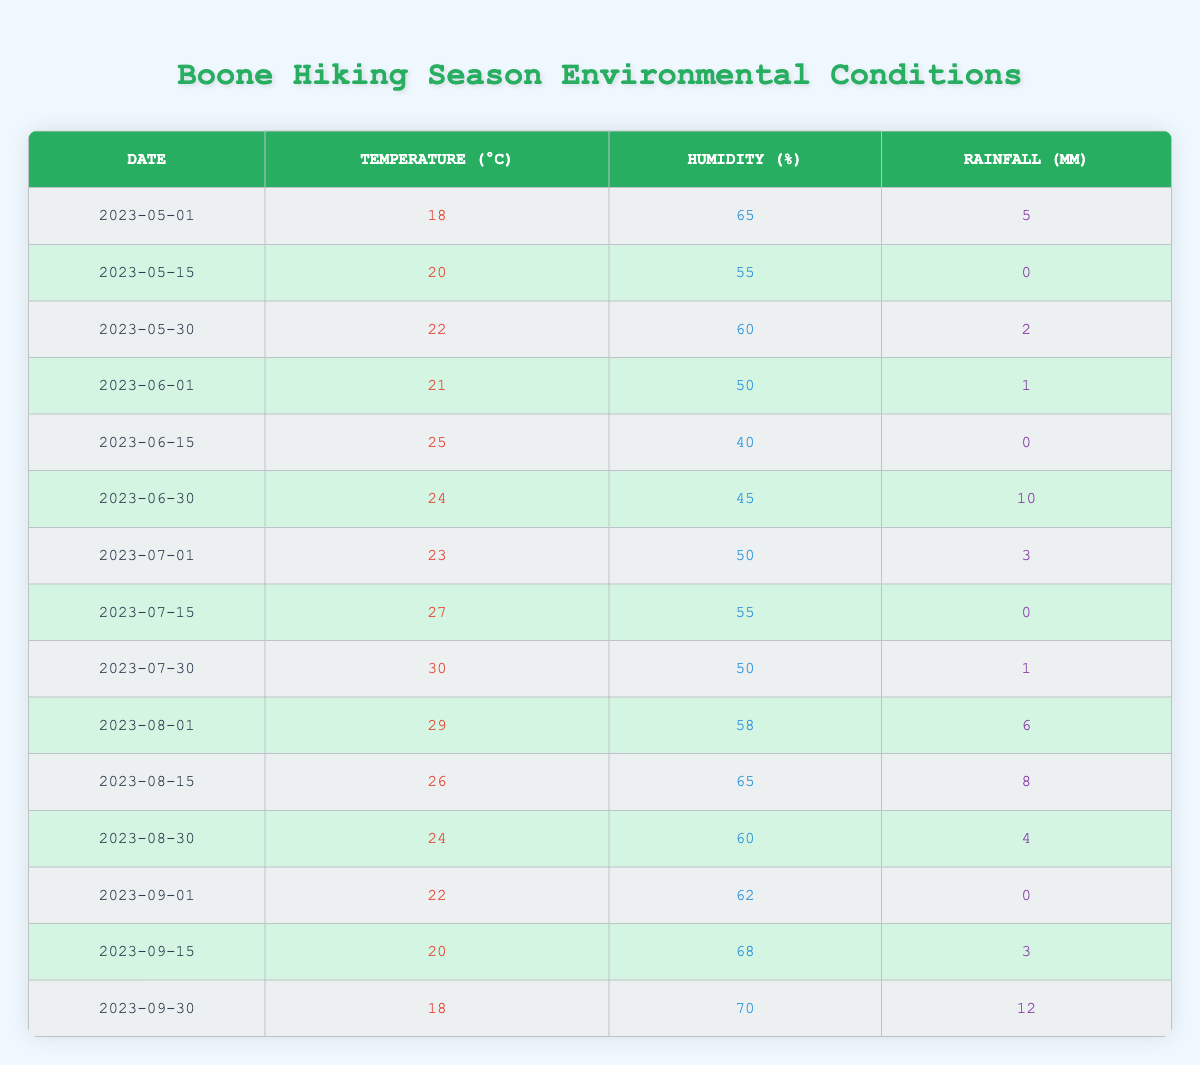What was the maximum temperature recorded during the hiking season? The maximum temperature can be found by scanning the temperature values in the table. The highest listed is 30°C on July 30, 2023.
Answer: 30°C What was the lowest humidity percentage recorded in the hiking season? By examining the humidity values, the lowest percentage is 40%, which occurred on June 15, 2023.
Answer: 40% How much total rainfall was recorded from May to September 2023? Adding the rainfall values: 5 + 0 + 2 + 1 + 0 + 10 + 3 + 0 + 1 + 6 + 8 + 4 + 0 + 3 + 12 = 51 mm. Thus, total rainfall is 51 mm.
Answer: 51 mm Which date had the highest humidity? By checking the humidity values, the highest percentage is 70%, recorded on September 30, 2023.
Answer: September 30, 2023 What is the average temperature across the hiking season? The temperatures are 18, 20, 22, 21, 25, 24, 23, 27, 30, 29, 26, 24, 22, 20, and 18. Adding them up gives 350; dividing by 15 (the number of entries) gives an average of 23.33°C.
Answer: 23.33°C Was there any rainfall on June 15, 2023? The rainfall for June 15 is listed as 0 mm, indicating no rainfall occurred on that date.
Answer: No What was the total number of days where the temperature was above 25°C? Checking for temperatures greater than 25°C, we see it was above 25°C on July 15 (27°C) and July 30 (30°C), totaling 3 days.
Answer: 3 days Was there consistent rainfall recorded in August? In August, the rainfall amounts were 6 mm (August 1), 8 mm (August 15), and 4 mm (August 30). All values are above 0 mm, indicating consistent rainfall.
Answer: Yes On which date did both temperature and humidity decrease compared to the previous data point? June 30 recorded 24°C (down from 25°C) with decreased humidity of 45% (down from 40%), indicating a decrease in both aspects.
Answer: June 30, 2023 How does the humidity compare between the first and last dates of the season? The humidity on the first date (May 1) was 65% while the last date (September 30) was 70%. The last date is higher by 5%.
Answer: Humidity increased by 5% What is the temperature difference between the hottest and coldest days in this record? The hottest day was July 30 with 30°C, and the coldest days, recorded twice, were at 18°C. The difference is calculated as 30 - 18 = 12°C.
Answer: 12°C 